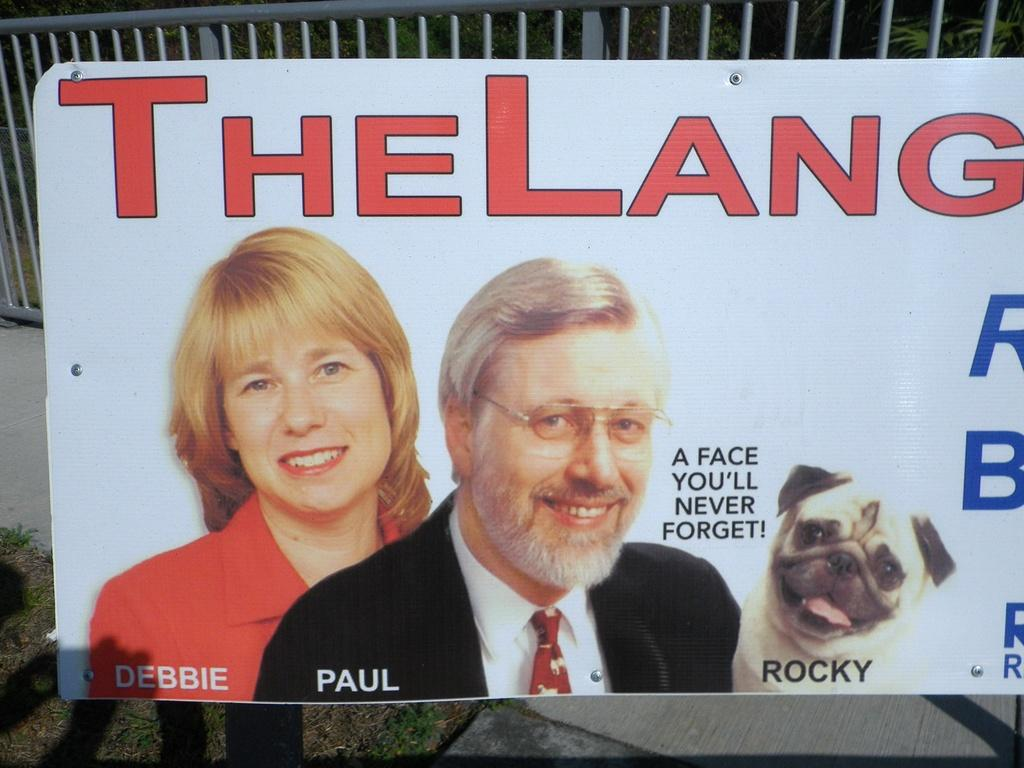What is the main object in the picture? There is a board in the picture. What can be seen on the board? The board has photos of a man, a woman, and a dog. Is there any text on the board? Yes, there is something written on the board. What can be seen in the background of the picture? There is a fence in the background of the picture. How many sheep can be seen in the picture? There are no sheep present in the picture; it features a board with photos of a man, a woman, and a dog. Can you hear the sound of a can opening in the picture? The picture is a still image, so there is no sound associated with it, including the sound of a can opening. 